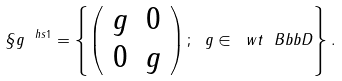Convert formula to latex. <formula><loc_0><loc_0><loc_500><loc_500>\S g ^ { \ h s 1 } = \left \{ \left ( \begin{array} { c c } g & 0 \\ 0 & g \end{array} \right ) ; \ g \in \ w t { \ B b b D } \right \} .</formula> 